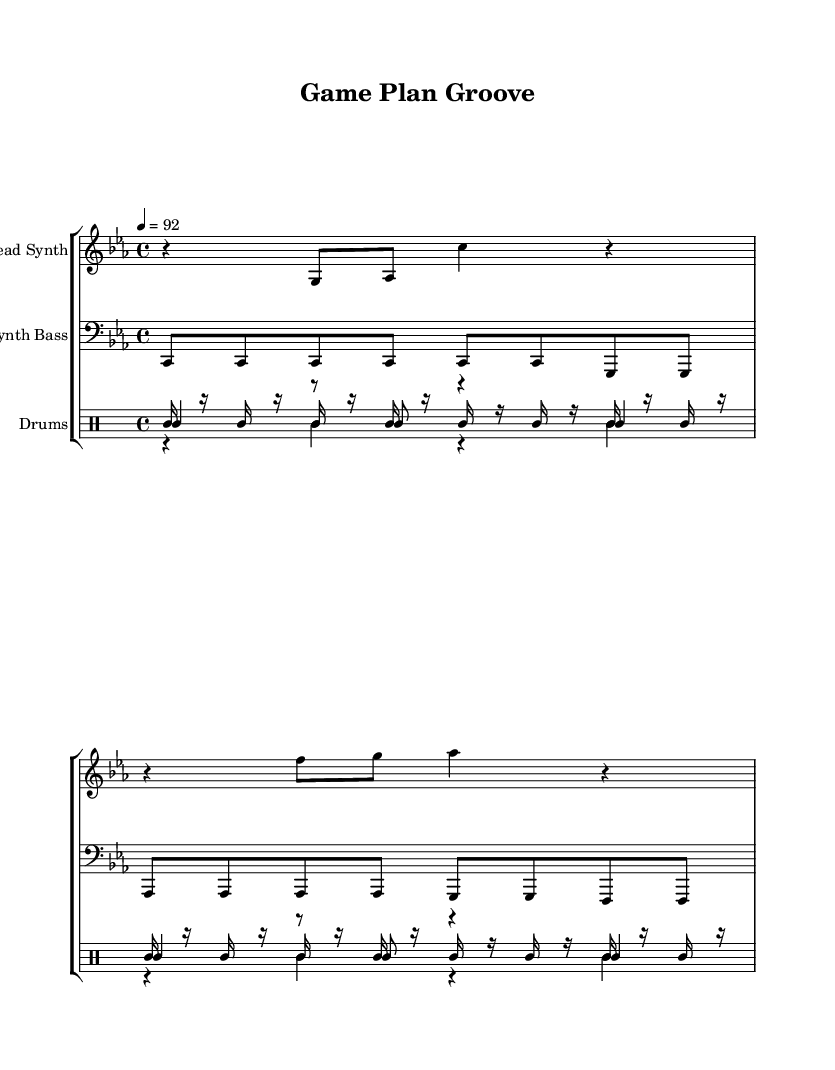What is the key signature of this music? The key signature is C minor, which has three flats (B♭, E♭, A♭). You can identify the key signature by looking at the beginning of the staff where the flats are indicated.
Answer: C minor What is the time signature of this music? The time signature shown at the beginning of the music is 4/4. This means there are four beats in each measure, and the quarter note gets one beat. The time signature is located directly after the key signature at the beginning of the sheet music.
Answer: 4/4 What is the tempo marking for this piece? The tempo marking is given as 92 beats per minute, indicated by the tempo instruction at the beginning. It directs the performer to play at a moderate speed. This tempo is noted above the staff or at the beginning of the score.
Answer: 92 How many measures of the lead synth part are there? The lead synth part consists of 2 measures, which can be counted by looking at the number of bar lines present in the section of the sheet music dedicated to the lead synth. Each measure is separated by a vertical line.
Answer: 2 Which instrument plays the bass line? The instrument playing the bass line is the Synth Bass, as indicated by its specific staff labeled at the beginning of that section. The clef also shows that the notes are meant to be played in the lower register typical for bass instruments.
Answer: Synth Bass What rhythmic pattern is used for the hi-hat? The hi-hat rhythm is a continuous pattern of sixteenth notes followed by rests. Each measure has alternating notes and rests, which gives it a driving, syncopated feel typical in hip hop music. This can be observed by looking at how the notes and rests are notated.
Answer: Sixteenth notes 